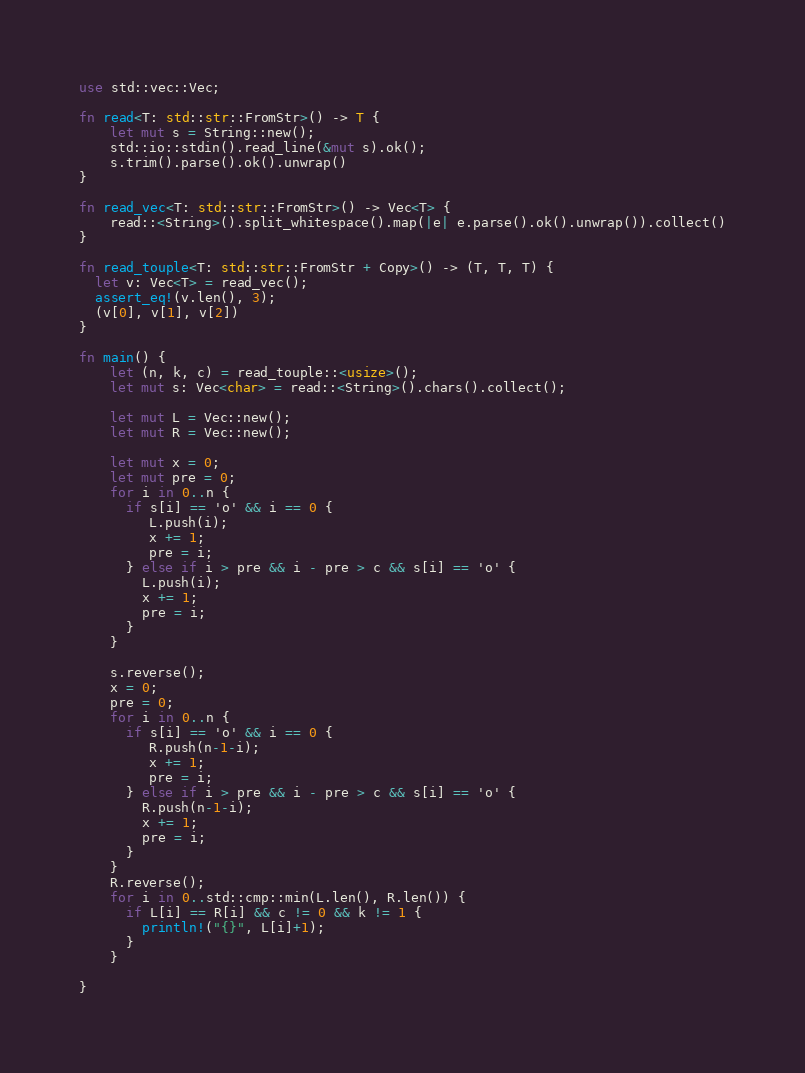<code> <loc_0><loc_0><loc_500><loc_500><_Rust_>use std::vec::Vec;

fn read<T: std::str::FromStr>() -> T {
    let mut s = String::new();
    std::io::stdin().read_line(&mut s).ok();
    s.trim().parse().ok().unwrap()
}

fn read_vec<T: std::str::FromStr>() -> Vec<T> {
    read::<String>().split_whitespace().map(|e| e.parse().ok().unwrap()).collect()
}

fn read_touple<T: std::str::FromStr + Copy>() -> (T, T, T) {
  let v: Vec<T> = read_vec();
  assert_eq!(v.len(), 3);
  (v[0], v[1], v[2])
}

fn main() {
    let (n, k, c) = read_touple::<usize>();
    let mut s: Vec<char> = read::<String>().chars().collect();

    let mut L = Vec::new();
    let mut R = Vec::new();

    let mut x = 0;
    let mut pre = 0;
    for i in 0..n {
      if s[i] == 'o' && i == 0 {
         L.push(i);
         x += 1;
         pre = i; 
      } else if i > pre && i - pre > c && s[i] == 'o' {
        L.push(i);
        x += 1;
        pre = i;
      }
    }

    s.reverse();
    x = 0;
    pre = 0;
    for i in 0..n {
      if s[i] == 'o' && i == 0 {
         R.push(n-1-i);
         x += 1;
         pre = i; 
      } else if i > pre && i - pre > c && s[i] == 'o' {
        R.push(n-1-i);
        x += 1;
        pre = i;
      }
    }  
    R.reverse();
    for i in 0..std::cmp::min(L.len(), R.len()) {
      if L[i] == R[i] && c != 0 && k != 1 {
        println!("{}", L[i]+1);
      }
    }

}
</code> 